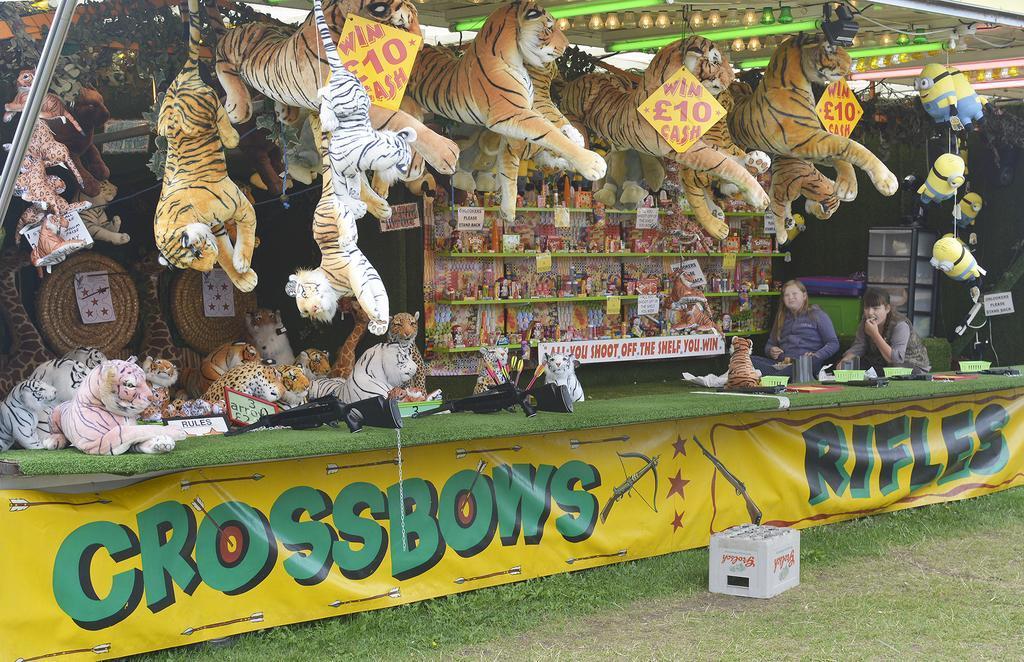Please provide a concise description of this image. In this image there is a stall with a banner, tray, baskets, arrows, toys in the shelves, boards, two persons, lights. 